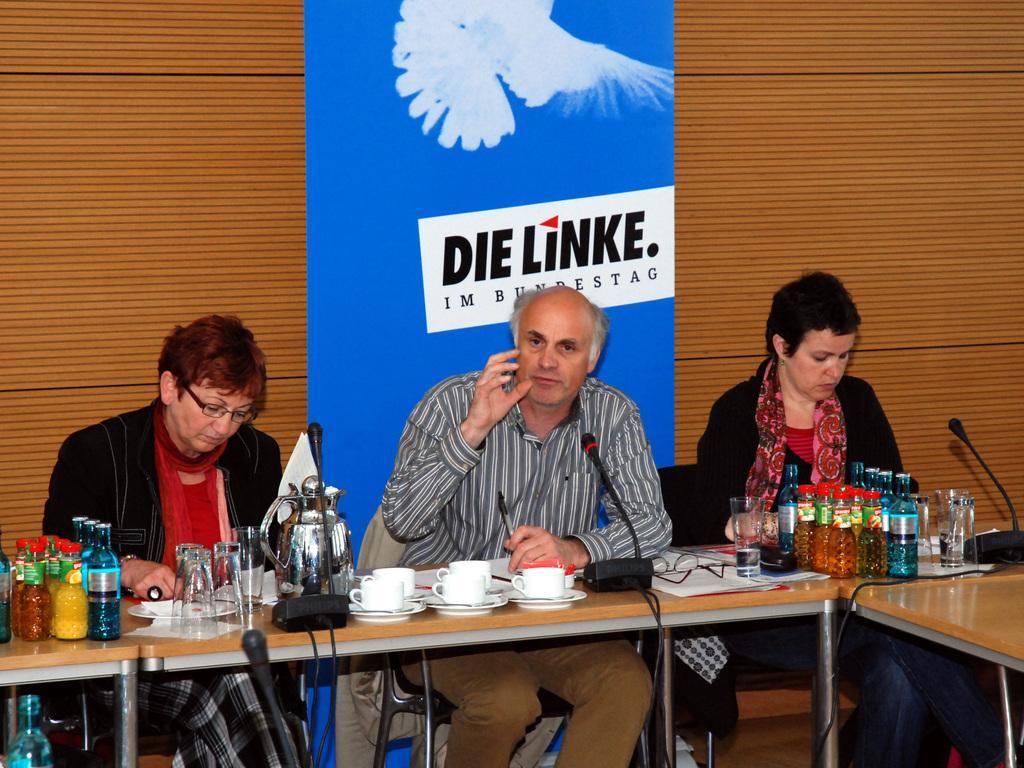Can you describe this image briefly? These persons are sitting on a chair. On this table there are bottles, mic, jar, cups, papers, spectacles and glasses. Backside of this person there is a banner in blue color. 